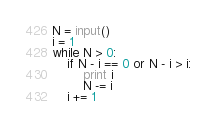Convert code to text. <code><loc_0><loc_0><loc_500><loc_500><_Python_>N = input()
i = 1
while N > 0:
    if N - i == 0 or N - i > i:
        print i
        N -= i
    i += 1
</code> 